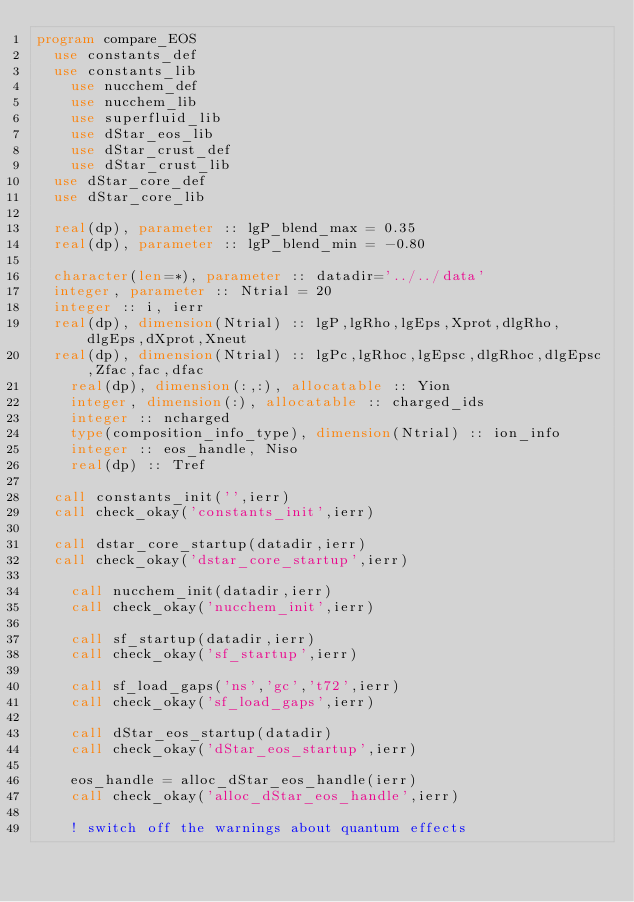Convert code to text. <code><loc_0><loc_0><loc_500><loc_500><_FORTRAN_>program compare_EOS
	use constants_def
	use constants_lib
    use nucchem_def
    use nucchem_lib
    use superfluid_lib
    use dStar_eos_lib
    use dStar_crust_def
    use dStar_crust_lib
	use dStar_core_def
	use dStar_core_lib

	real(dp), parameter :: lgP_blend_max = 0.35
	real(dp), parameter :: lgP_blend_min = -0.80

	character(len=*), parameter :: datadir='../../data'
	integer, parameter :: Ntrial = 20
	integer :: i, ierr
	real(dp), dimension(Ntrial) :: lgP,lgRho,lgEps,Xprot,dlgRho,dlgEps,dXprot,Xneut
	real(dp), dimension(Ntrial) :: lgPc,lgRhoc,lgEpsc,dlgRhoc,dlgEpsc,Zfac,fac,dfac
    real(dp), dimension(:,:), allocatable :: Yion
    integer, dimension(:), allocatable :: charged_ids
    integer :: ncharged
    type(composition_info_type), dimension(Ntrial) :: ion_info
    integer :: eos_handle, Niso
    real(dp) :: Tref
	
	call constants_init('',ierr)
	call check_okay('constants_init',ierr)

	call dstar_core_startup(datadir,ierr)
	call check_okay('dstar_core_startup',ierr)
    
    call nucchem_init(datadir,ierr)
    call check_okay('nucchem_init',ierr)
	
    call sf_startup(datadir,ierr)
    call check_okay('sf_startup',ierr)
	
    call sf_load_gaps('ns','gc','t72',ierr)
    call check_okay('sf_load_gaps',ierr)
	
    call dStar_eos_startup(datadir)
    call check_okay('dStar_eos_startup',ierr)
	
    eos_handle = alloc_dStar_eos_handle(ierr)
    call check_okay('alloc_dStar_eos_handle',ierr)
    
    ! switch off the warnings about quantum effects</code> 